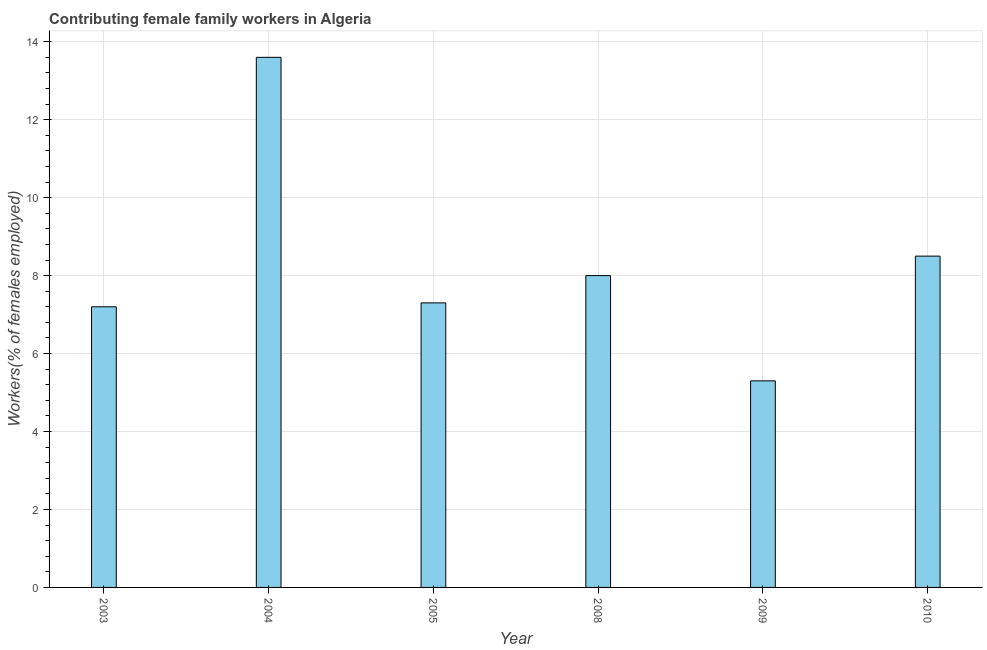Does the graph contain any zero values?
Your answer should be compact. No. What is the title of the graph?
Keep it short and to the point. Contributing female family workers in Algeria. What is the label or title of the X-axis?
Provide a short and direct response. Year. What is the label or title of the Y-axis?
Offer a terse response. Workers(% of females employed). Across all years, what is the maximum contributing female family workers?
Make the answer very short. 13.6. Across all years, what is the minimum contributing female family workers?
Provide a short and direct response. 5.3. In which year was the contributing female family workers minimum?
Your answer should be compact. 2009. What is the sum of the contributing female family workers?
Your answer should be very brief. 49.9. What is the difference between the contributing female family workers in 2003 and 2005?
Make the answer very short. -0.1. What is the average contributing female family workers per year?
Provide a short and direct response. 8.32. What is the median contributing female family workers?
Provide a succinct answer. 7.65. In how many years, is the contributing female family workers greater than 4.4 %?
Keep it short and to the point. 6. Do a majority of the years between 2008 and 2009 (inclusive) have contributing female family workers greater than 2.8 %?
Offer a very short reply. Yes. What is the ratio of the contributing female family workers in 2003 to that in 2008?
Your answer should be very brief. 0.9. Is the difference between the contributing female family workers in 2004 and 2008 greater than the difference between any two years?
Ensure brevity in your answer.  No. What is the difference between the highest and the second highest contributing female family workers?
Ensure brevity in your answer.  5.1. What is the difference between the highest and the lowest contributing female family workers?
Offer a terse response. 8.3. In how many years, is the contributing female family workers greater than the average contributing female family workers taken over all years?
Your answer should be very brief. 2. Are all the bars in the graph horizontal?
Provide a succinct answer. No. What is the Workers(% of females employed) in 2003?
Your answer should be compact. 7.2. What is the Workers(% of females employed) in 2004?
Your answer should be compact. 13.6. What is the Workers(% of females employed) of 2005?
Your response must be concise. 7.3. What is the Workers(% of females employed) of 2008?
Ensure brevity in your answer.  8. What is the Workers(% of females employed) in 2009?
Make the answer very short. 5.3. What is the Workers(% of females employed) in 2010?
Offer a very short reply. 8.5. What is the difference between the Workers(% of females employed) in 2003 and 2005?
Make the answer very short. -0.1. What is the difference between the Workers(% of females employed) in 2003 and 2008?
Your answer should be very brief. -0.8. What is the difference between the Workers(% of females employed) in 2004 and 2008?
Your answer should be very brief. 5.6. What is the difference between the Workers(% of females employed) in 2004 and 2009?
Offer a very short reply. 8.3. What is the difference between the Workers(% of females employed) in 2004 and 2010?
Your answer should be compact. 5.1. What is the difference between the Workers(% of females employed) in 2005 and 2009?
Your answer should be very brief. 2. What is the difference between the Workers(% of females employed) in 2005 and 2010?
Your answer should be compact. -1.2. What is the difference between the Workers(% of females employed) in 2008 and 2010?
Offer a terse response. -0.5. What is the ratio of the Workers(% of females employed) in 2003 to that in 2004?
Offer a terse response. 0.53. What is the ratio of the Workers(% of females employed) in 2003 to that in 2005?
Make the answer very short. 0.99. What is the ratio of the Workers(% of females employed) in 2003 to that in 2008?
Provide a succinct answer. 0.9. What is the ratio of the Workers(% of females employed) in 2003 to that in 2009?
Your answer should be compact. 1.36. What is the ratio of the Workers(% of females employed) in 2003 to that in 2010?
Keep it short and to the point. 0.85. What is the ratio of the Workers(% of females employed) in 2004 to that in 2005?
Your answer should be compact. 1.86. What is the ratio of the Workers(% of females employed) in 2004 to that in 2009?
Provide a short and direct response. 2.57. What is the ratio of the Workers(% of females employed) in 2005 to that in 2009?
Provide a short and direct response. 1.38. What is the ratio of the Workers(% of females employed) in 2005 to that in 2010?
Offer a very short reply. 0.86. What is the ratio of the Workers(% of females employed) in 2008 to that in 2009?
Ensure brevity in your answer.  1.51. What is the ratio of the Workers(% of females employed) in 2008 to that in 2010?
Offer a terse response. 0.94. What is the ratio of the Workers(% of females employed) in 2009 to that in 2010?
Your answer should be compact. 0.62. 